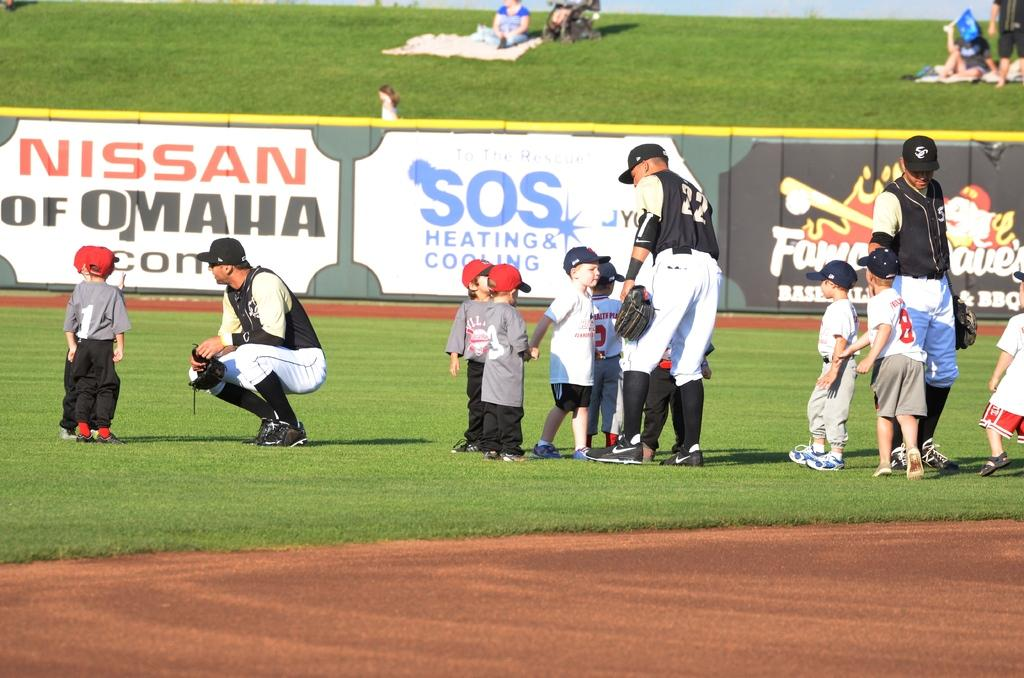<image>
Present a compact description of the photo's key features. small kids speaking with adult ball players with a nissan of omaha banner in the background 